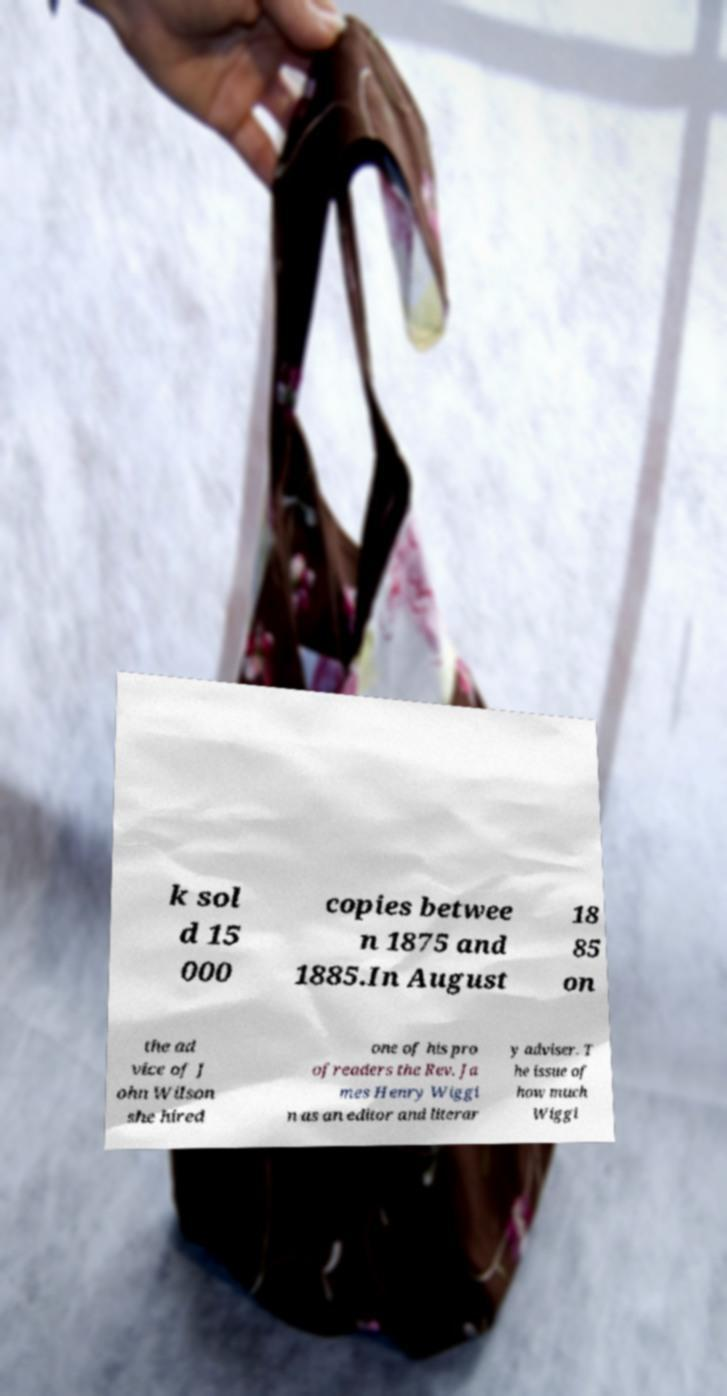There's text embedded in this image that I need extracted. Can you transcribe it verbatim? k sol d 15 000 copies betwee n 1875 and 1885.In August 18 85 on the ad vice of J ohn Wilson she hired one of his pro ofreaders the Rev. Ja mes Henry Wiggi n as an editor and literar y adviser. T he issue of how much Wiggi 